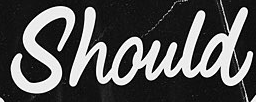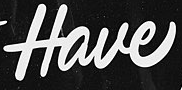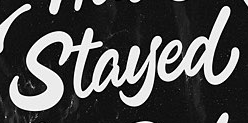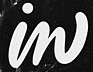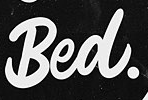Read the text content from these images in order, separated by a semicolon. Should; Have; Stayed; in; Bed. 